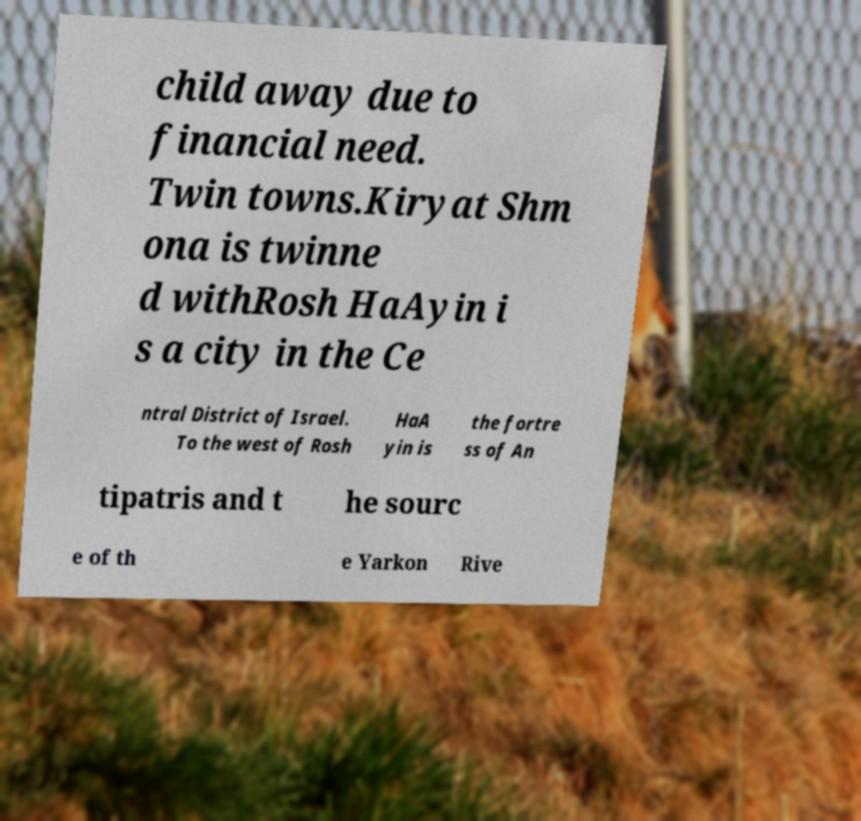I need the written content from this picture converted into text. Can you do that? child away due to financial need. Twin towns.Kiryat Shm ona is twinne d withRosh HaAyin i s a city in the Ce ntral District of Israel. To the west of Rosh HaA yin is the fortre ss of An tipatris and t he sourc e of th e Yarkon Rive 